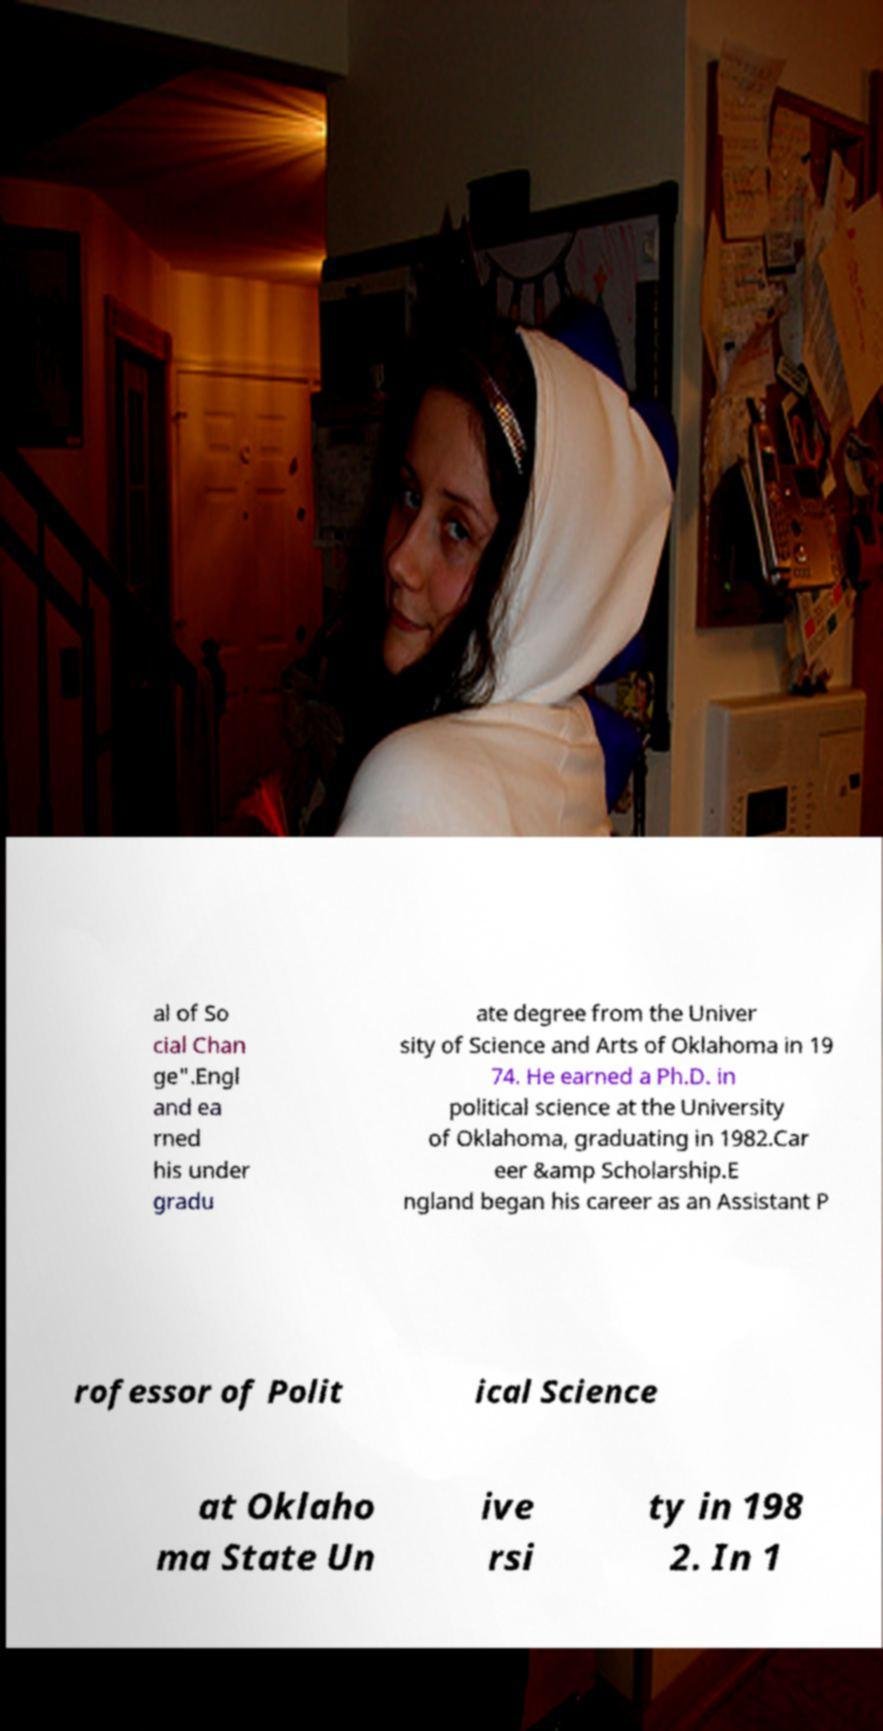There's text embedded in this image that I need extracted. Can you transcribe it verbatim? al of So cial Chan ge".Engl and ea rned his under gradu ate degree from the Univer sity of Science and Arts of Oklahoma in 19 74. He earned a Ph.D. in political science at the University of Oklahoma, graduating in 1982.Car eer &amp Scholarship.E ngland began his career as an Assistant P rofessor of Polit ical Science at Oklaho ma State Un ive rsi ty in 198 2. In 1 